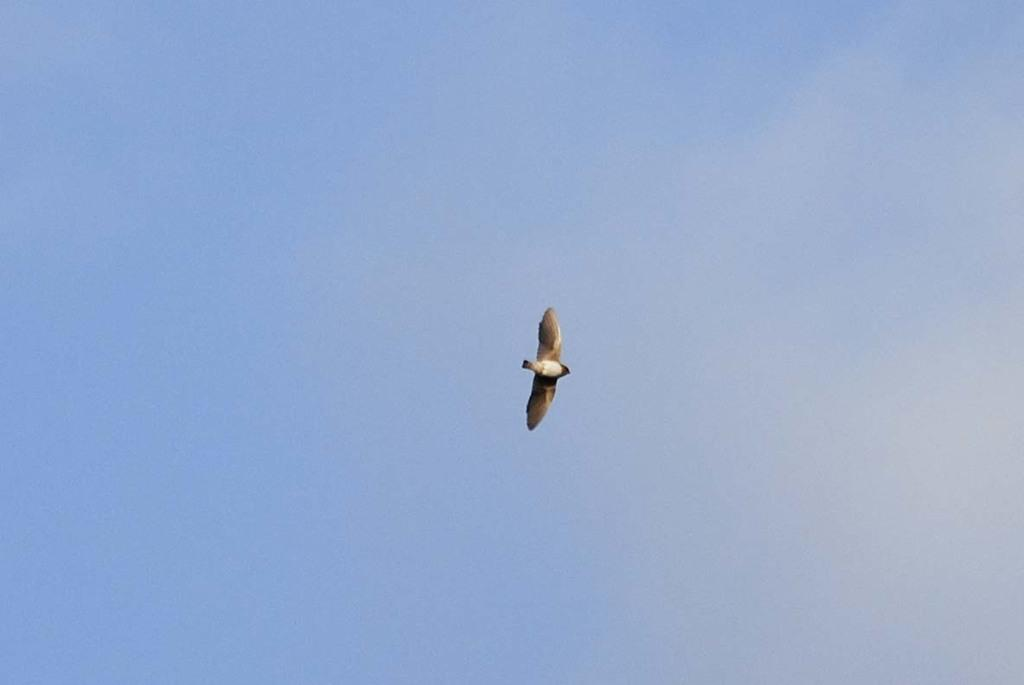What type of animal is in the image? There is a bird in the image. What is the bird doing in the image? The bird is flying in the sky. Where is the monkey located in the image? There is no monkey present in the image; it only features a bird flying in the sky. What type of beast can be seen running on the ground in the image? There is no beast running on the ground in the image; it only features a bird flying in the sky. 